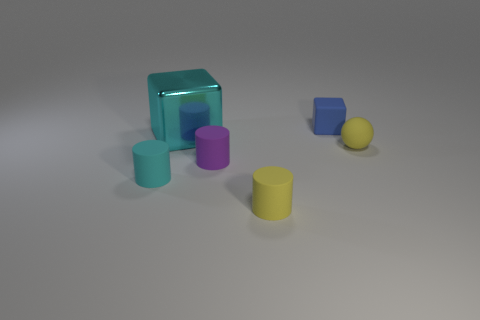Is the tiny cube made of the same material as the big object?
Provide a short and direct response. No. What number of large red things are there?
Make the answer very short. 0. The tiny thing that is left of the cyan object right of the cylinder that is to the left of the big metallic thing is what color?
Your answer should be compact. Cyan. How many objects are both behind the cyan matte cylinder and in front of the cyan block?
Keep it short and to the point. 2. What number of metal objects are either big balls or small objects?
Your response must be concise. 0. What material is the tiny object on the right side of the tiny thing that is behind the big cyan shiny thing made of?
Your answer should be compact. Rubber. What is the shape of the small matte object that is the same color as the big cube?
Provide a succinct answer. Cylinder. The cyan matte thing that is the same size as the purple cylinder is what shape?
Keep it short and to the point. Cylinder. Are there fewer small cyan rubber objects than yellow objects?
Your answer should be very brief. Yes. There is a object in front of the small cyan matte object; are there any cyan blocks that are in front of it?
Ensure brevity in your answer.  No. 